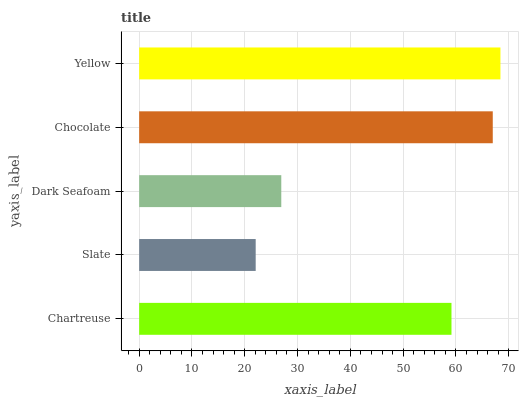Is Slate the minimum?
Answer yes or no. Yes. Is Yellow the maximum?
Answer yes or no. Yes. Is Dark Seafoam the minimum?
Answer yes or no. No. Is Dark Seafoam the maximum?
Answer yes or no. No. Is Dark Seafoam greater than Slate?
Answer yes or no. Yes. Is Slate less than Dark Seafoam?
Answer yes or no. Yes. Is Slate greater than Dark Seafoam?
Answer yes or no. No. Is Dark Seafoam less than Slate?
Answer yes or no. No. Is Chartreuse the high median?
Answer yes or no. Yes. Is Chartreuse the low median?
Answer yes or no. Yes. Is Slate the high median?
Answer yes or no. No. Is Dark Seafoam the low median?
Answer yes or no. No. 